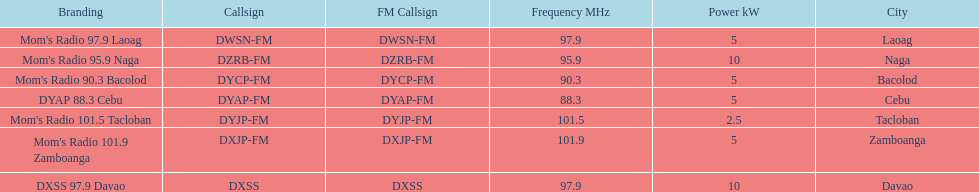How many times is the frequency greater than 95? 5. 